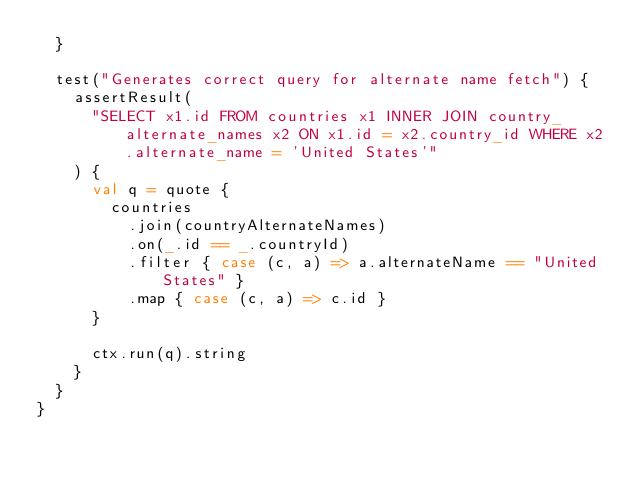<code> <loc_0><loc_0><loc_500><loc_500><_Scala_>  }

  test("Generates correct query for alternate name fetch") {
    assertResult(
      "SELECT x1.id FROM countries x1 INNER JOIN country_alternate_names x2 ON x1.id = x2.country_id WHERE x2.alternate_name = 'United States'"
    ) {
      val q = quote {
        countries
          .join(countryAlternateNames)
          .on(_.id == _.countryId)
          .filter { case (c, a) => a.alternateName == "United States" }
          .map { case (c, a) => c.id }
      }

      ctx.run(q).string
    }
  }
}
</code> 